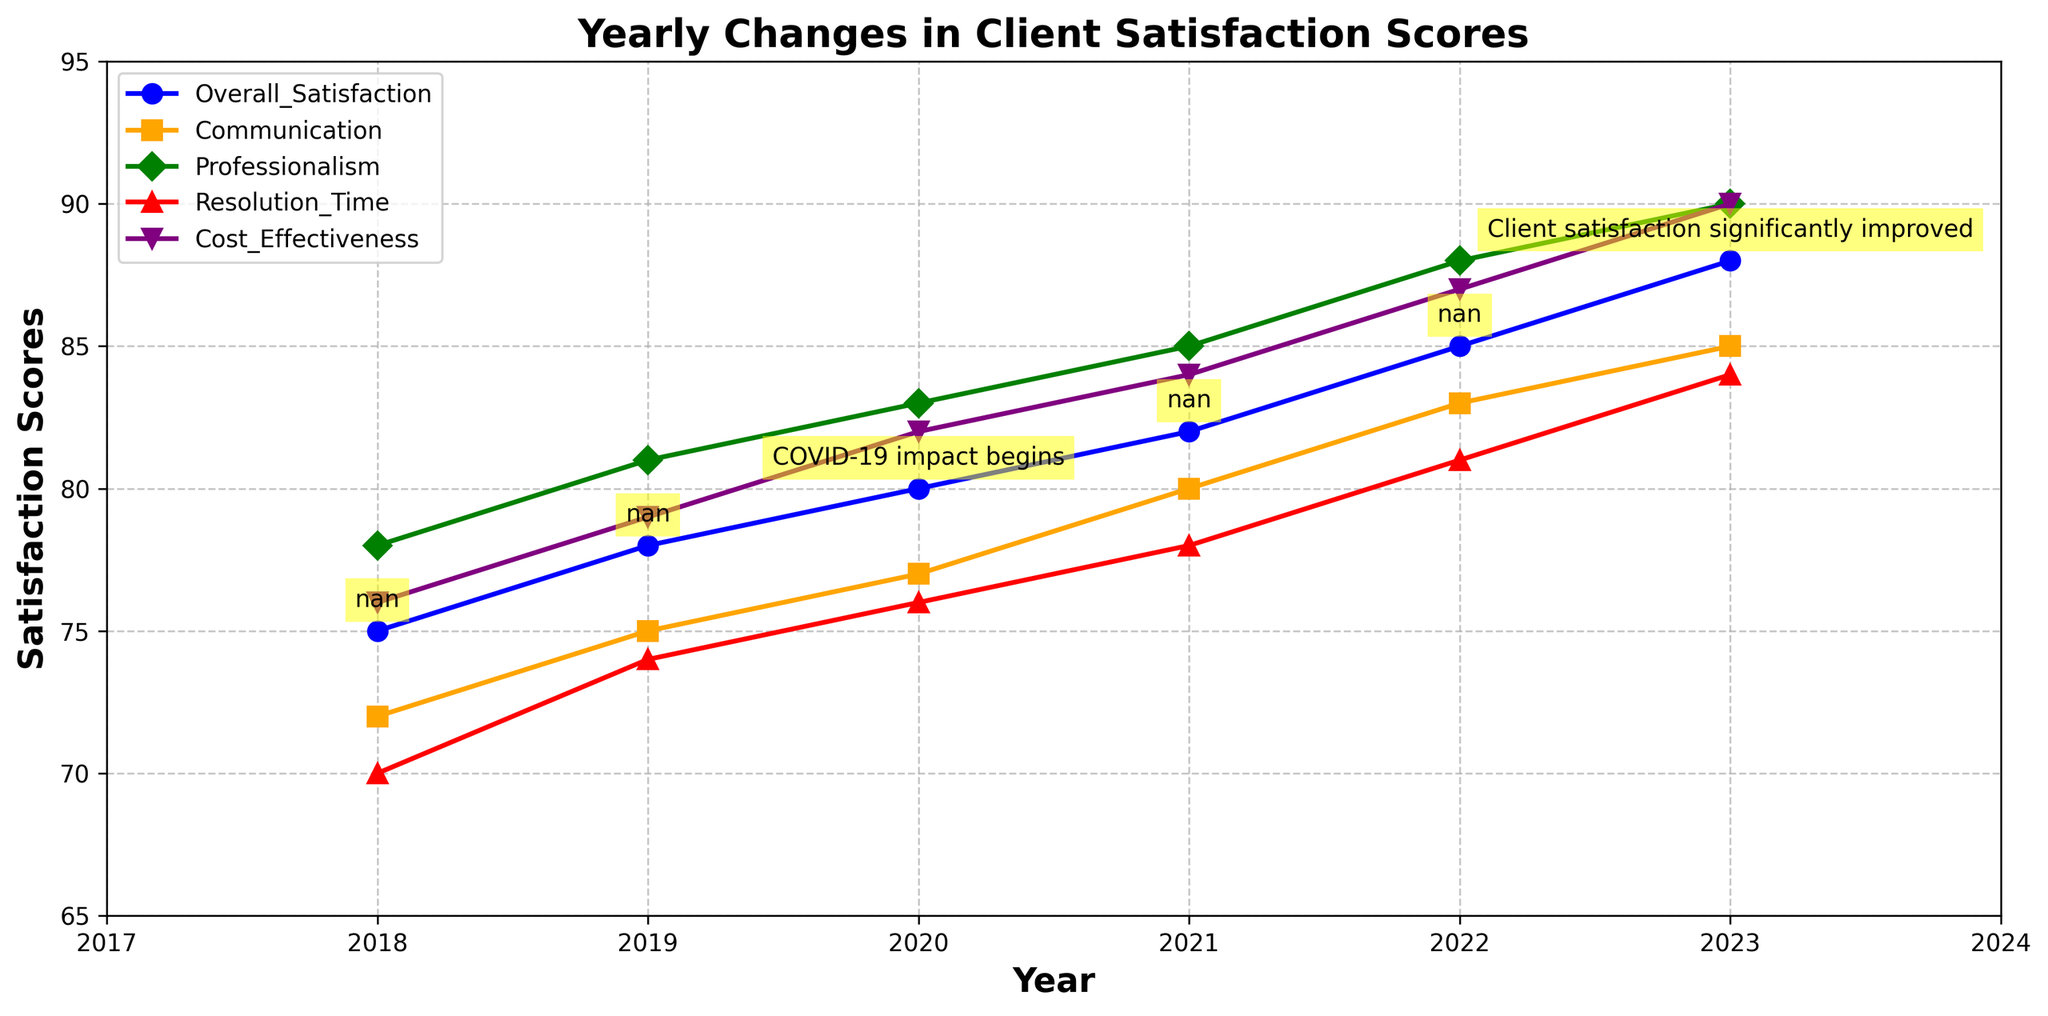What year does the annotation indicate the COVID-19 impact begins? The annotation "COVID-19 impact begins" is placed at the data point corresponding to the year 2020.
Answer: 2020 What is the trend in the Overall Satisfaction score from 2018 to 2023? The Overall Satisfaction score increases consistently year by year from 75 in 2018 to 88 in 2023.
Answer: Increasing In what year does the Overall Satisfaction score reach 85? The Overall Satisfaction score reaches 85 in the year 2022, as indicated by the figure.
Answer: 2022 Which feedback category has the highest score in 2023? In the year 2023, the Professionalism category has the highest score, which is 90.
Answer: Professionalism How does the Communication score in 2023 compare to the Communication score in 2018? To compare the scores, note that the Communication score in 2018 is 72 and in 2023 it is 85. Therefore, the score increases by 13 points.
Answer: Increased by 13 Between which years did the Resolution Time score show the greatest improvement? The Resolution Time score improved from 70 in 2018 to 74 in 2019, by 4 points. Comparing yearly changes, the greatest improvement is between 2022 and 2023, where the score increased from 81 to 84, by 3 points.
Answer: Between 2022 and 2023 How many categories had scores greater than or equal to 85 in 2021? In 2021, the chart shows that Professionalism (85) is the only category that had a score of 85 or higher.
Answer: 1 category What is the average of the Overall Satisfaction scores from 2018 to 2023? The Overall Satisfaction scores from 2018 to 2023 are 75, 78, 80, 82, 85, and 88. Summing these scores gives 488. Dividing by the number of years (6) results in an average of 81.33.
Answer: 81.33 In which year did client satisfaction significantly improve according to the annotation? The annotation "Client satisfaction significantly improved" is placed at the data point corresponding to the year 2023.
Answer: 2023 Which category shows the least improvement from 2018 to 2023? To determine the least improvement, calculate the difference for each category between 2018 and 2023: Overall (88-75=13), Communication (85-72=13), Professionalism (90-78=12), Resolution Time (84-70=14), Cost Effectiveness (90-76=14). The Professionalism category shows the least improvement with a change of 12 points.
Answer: Professionalism 